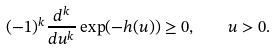<formula> <loc_0><loc_0><loc_500><loc_500>( - 1 ) ^ { k } \frac { d ^ { k } } { d u ^ { k } } \exp ( - h ( u ) ) \geq 0 , \quad u > 0 .</formula> 